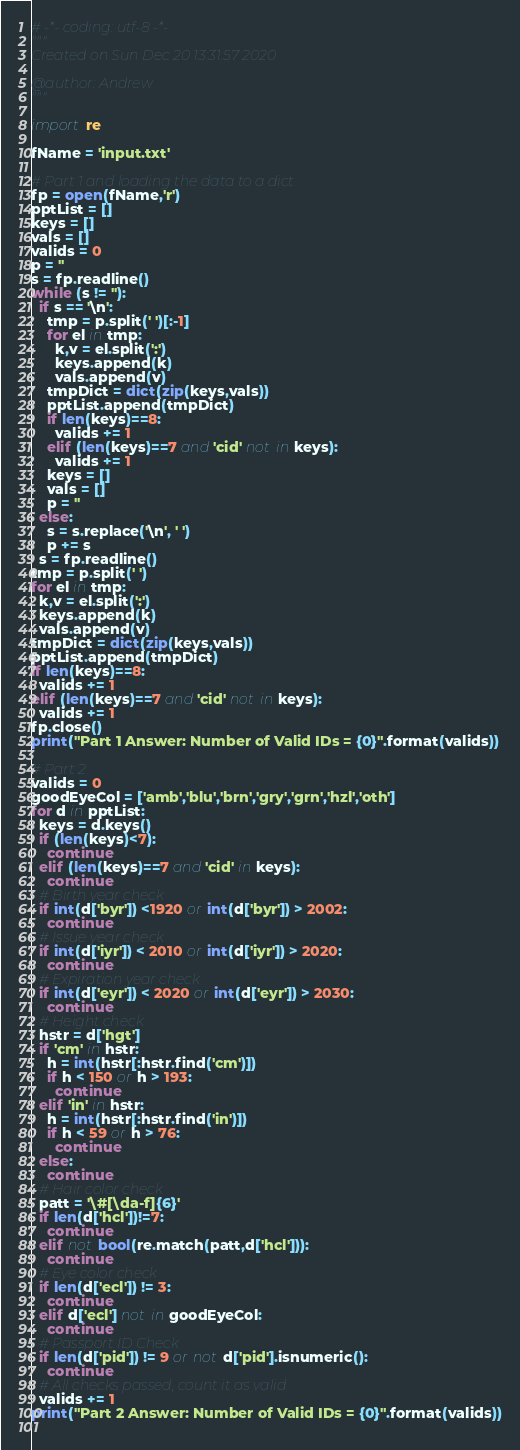<code> <loc_0><loc_0><loc_500><loc_500><_Python_># -*- coding: utf-8 -*-
"""
Created on Sun Dec 20 13:31:57 2020

@author: Andrew
"""

import re

fName = 'input.txt'

# Part 1 and loading the data to a dict
fp = open(fName,'r')
pptList = []
keys = []
vals = []
valids = 0
p = ''
s = fp.readline()
while (s != ''):
  if s == '\n':
    tmp = p.split(' ')[:-1]
    for el in tmp:
      k,v = el.split(':')
      keys.append(k)
      vals.append(v)
    tmpDict = dict(zip(keys,vals))
    pptList.append(tmpDict)
    if len(keys)==8:
      valids += 1
    elif (len(keys)==7 and 'cid' not in keys):
      valids += 1
    keys = []
    vals = []
    p = ''
  else:
    s = s.replace('\n', ' ')
    p += s
  s = fp.readline()
tmp = p.split(' ')
for el in tmp:
  k,v = el.split(':')
  keys.append(k)
  vals.append(v)
tmpDict = dict(zip(keys,vals))
pptList.append(tmpDict)
if len(keys)==8:
  valids += 1
elif (len(keys)==7 and 'cid' not in keys):
  valids += 1
fp.close()
print("Part 1 Answer: Number of Valid IDs = {0}".format(valids))

# Part 2
valids = 0
goodEyeCol = ['amb','blu','brn','gry','grn','hzl','oth']
for d in pptList:
  keys = d.keys()
  if (len(keys)<7):
    continue
  elif (len(keys)==7 and 'cid' in keys):
    continue
  # Birth year check
  if int(d['byr']) <1920 or int(d['byr']) > 2002:
    continue
  # Issue year check
  if int(d['iyr']) < 2010 or int(d['iyr']) > 2020:
    continue
  # Expiration year check
  if int(d['eyr']) < 2020 or int(d['eyr']) > 2030:
    continue
  # Height check
  hstr = d['hgt']
  if 'cm' in hstr:
    h = int(hstr[:hstr.find('cm')])
    if h < 150 or h > 193:
      continue
  elif 'in' in hstr:
    h = int(hstr[:hstr.find('in')])
    if h < 59 or h > 76:
      continue
  else:
    continue
  # Hair color check
  patt = '\#[\da-f]{6}'
  if len(d['hcl'])!=7:
    continue
  elif not bool(re.match(patt,d['hcl'])):
    continue
  # Eye color check
  if len(d['ecl']) != 3:
    continue
  elif d['ecl'] not in goodEyeCol:
    continue
  # Passport ID Check
  if len(d['pid']) != 9 or not d['pid'].isnumeric():
    continue
  # All checks passed, count it as valid
  valids += 1
print("Part 2 Answer: Number of Valid IDs = {0}".format(valids))
  </code> 